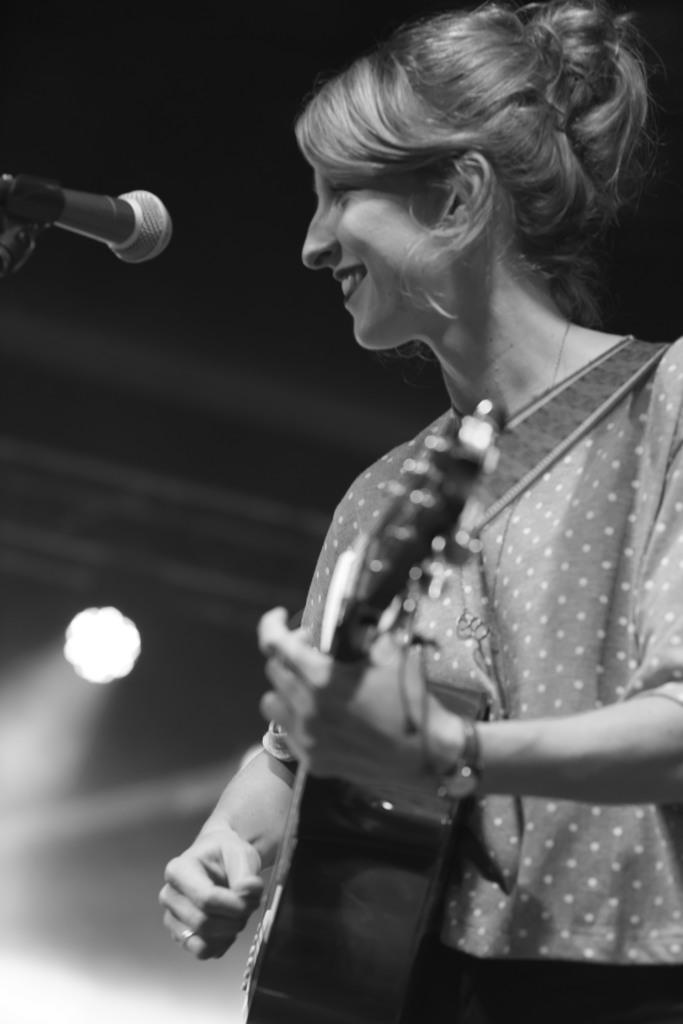Who is the main subject in the image? There is a lady in the image. What is the lady doing in the image? The lady is standing and holding a guitar. What can be seen on the left side of the image? There is a microphone on the left side of the image. What is visible in the background of the image? There is a light in the background of the image. What type of jeans is the lady wearing in the image? There is no information about the lady's jeans in the image, so we cannot determine what type she is wearing. How many clams can be seen on the lady's head in the image? There are no clams present in the image. 